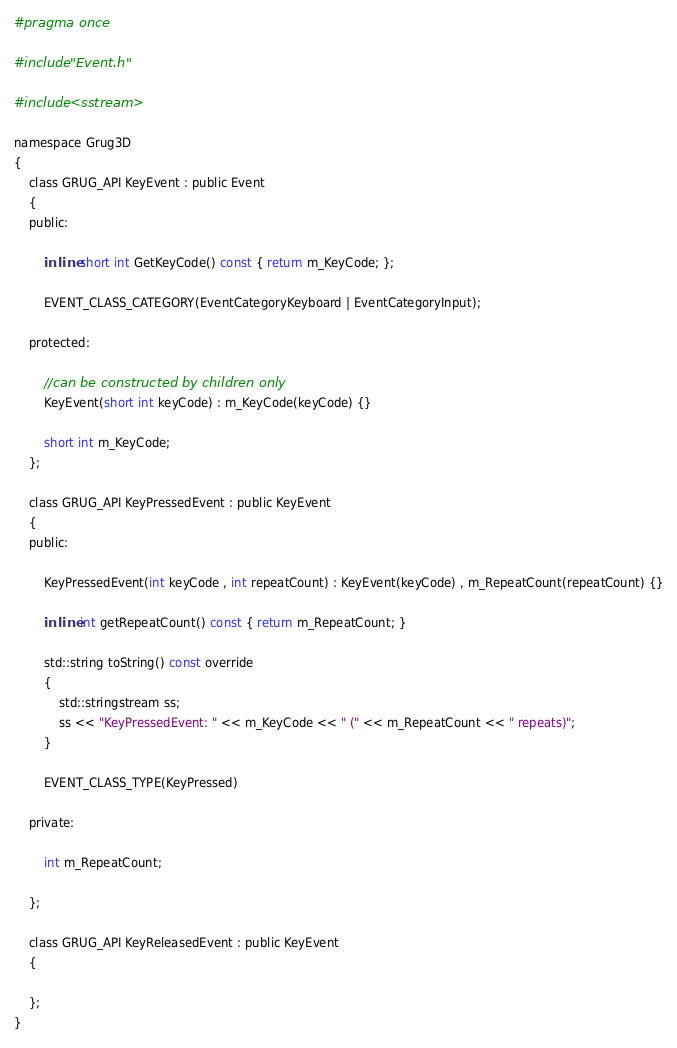Convert code to text. <code><loc_0><loc_0><loc_500><loc_500><_C_>#pragma once

#include "Event.h"

#include <sstream>

namespace Grug3D
{
	class GRUG_API KeyEvent : public Event
	{
	public:

		inline short int GetKeyCode() const { return m_KeyCode; };

		EVENT_CLASS_CATEGORY(EventCategoryKeyboard | EventCategoryInput);

	protected:

		//can be constructed by children only
		KeyEvent(short int keyCode) : m_KeyCode(keyCode) {}

		short int m_KeyCode;
	};

	class GRUG_API KeyPressedEvent : public KeyEvent
	{
	public:

		KeyPressedEvent(int keyCode , int repeatCount) : KeyEvent(keyCode) , m_RepeatCount(repeatCount) {}

		inline int getRepeatCount() const { return m_RepeatCount; }

		std::string toString() const override
		{
			std::stringstream ss;
			ss << "KeyPressedEvent: " << m_KeyCode << " (" << m_RepeatCount << " repeats)";
		}

		EVENT_CLASS_TYPE(KeyPressed)

	private:

		int m_RepeatCount;

	};

	class GRUG_API KeyReleasedEvent : public KeyEvent
	{

	};
}</code> 